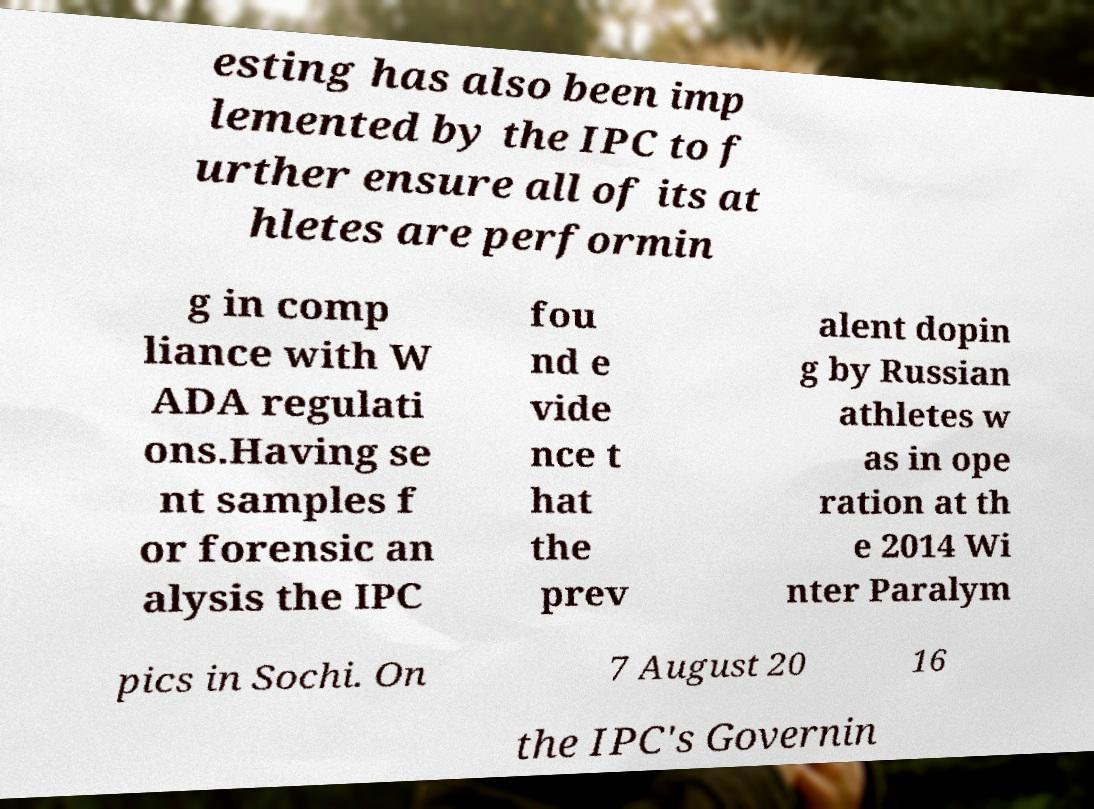What messages or text are displayed in this image? I need them in a readable, typed format. esting has also been imp lemented by the IPC to f urther ensure all of its at hletes are performin g in comp liance with W ADA regulati ons.Having se nt samples f or forensic an alysis the IPC fou nd e vide nce t hat the prev alent dopin g by Russian athletes w as in ope ration at th e 2014 Wi nter Paralym pics in Sochi. On 7 August 20 16 the IPC's Governin 